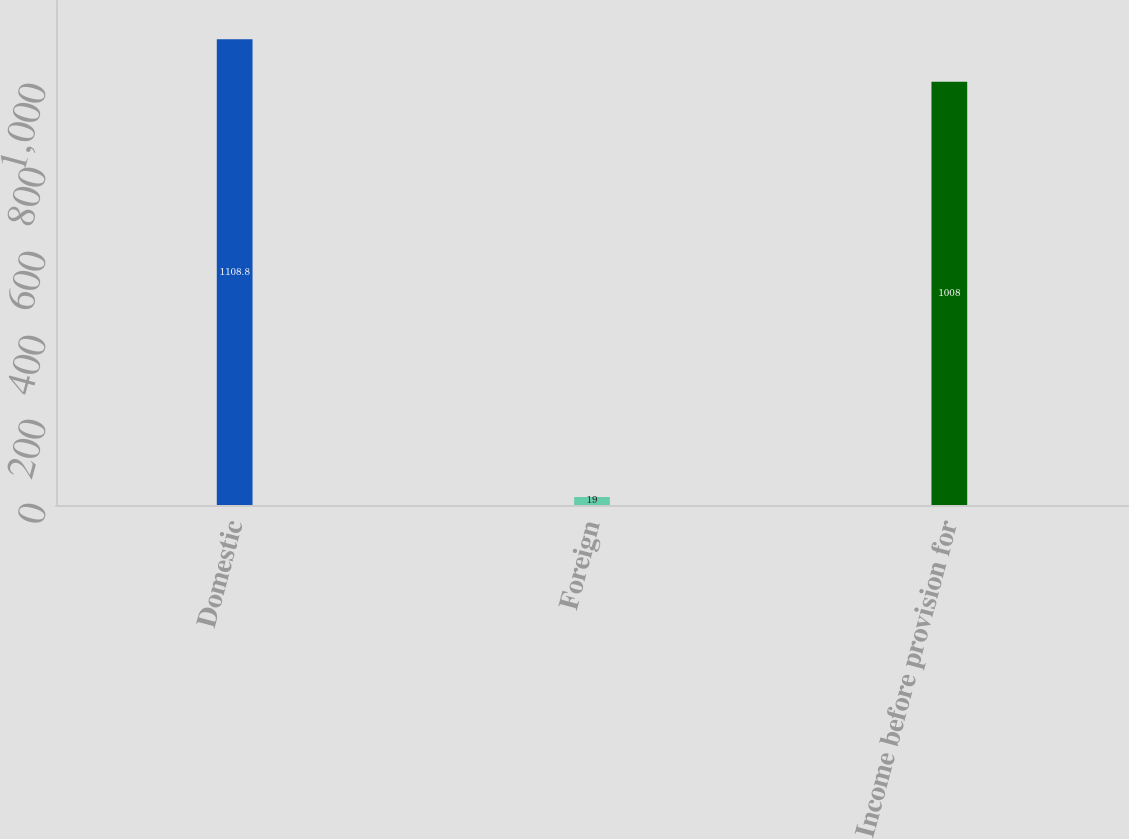<chart> <loc_0><loc_0><loc_500><loc_500><bar_chart><fcel>Domestic<fcel>Foreign<fcel>Income before provision for<nl><fcel>1108.8<fcel>19<fcel>1008<nl></chart> 